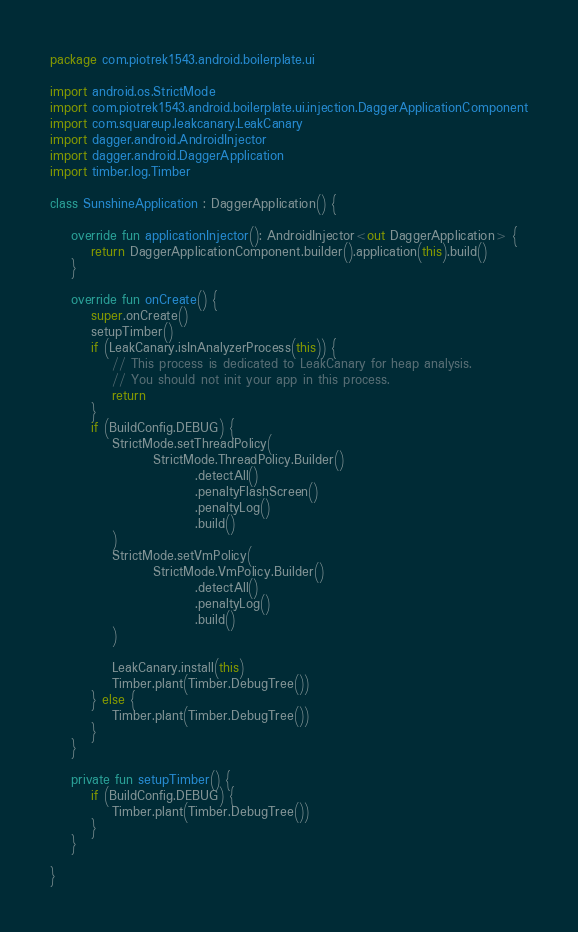<code> <loc_0><loc_0><loc_500><loc_500><_Kotlin_>package com.piotrek1543.android.boilerplate.ui

import android.os.StrictMode
import com.piotrek1543.android.boilerplate.ui.injection.DaggerApplicationComponent
import com.squareup.leakcanary.LeakCanary
import dagger.android.AndroidInjector
import dagger.android.DaggerApplication
import timber.log.Timber

class SunshineApplication : DaggerApplication() {

    override fun applicationInjector(): AndroidInjector<out DaggerApplication> {
        return DaggerApplicationComponent.builder().application(this).build()
    }

    override fun onCreate() {
        super.onCreate()
        setupTimber()
        if (LeakCanary.isInAnalyzerProcess(this)) {
            // This process is dedicated to LeakCanary for heap analysis.
            // You should not init your app in this process.
            return
        }
        if (BuildConfig.DEBUG) {
            StrictMode.setThreadPolicy(
                    StrictMode.ThreadPolicy.Builder()
                            .detectAll()
                            .penaltyFlashScreen()
                            .penaltyLog()
                            .build()
            )
            StrictMode.setVmPolicy(
                    StrictMode.VmPolicy.Builder()
                            .detectAll()
                            .penaltyLog()
                            .build()
            )

            LeakCanary.install(this)
            Timber.plant(Timber.DebugTree())
        } else {
            Timber.plant(Timber.DebugTree())
        }
    }

    private fun setupTimber() {
        if (BuildConfig.DEBUG) {
            Timber.plant(Timber.DebugTree())
        }
    }

}
</code> 